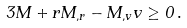Convert formula to latex. <formula><loc_0><loc_0><loc_500><loc_500>3 M + r M _ { , r } - M _ { , v } v \geq 0 \, .</formula> 